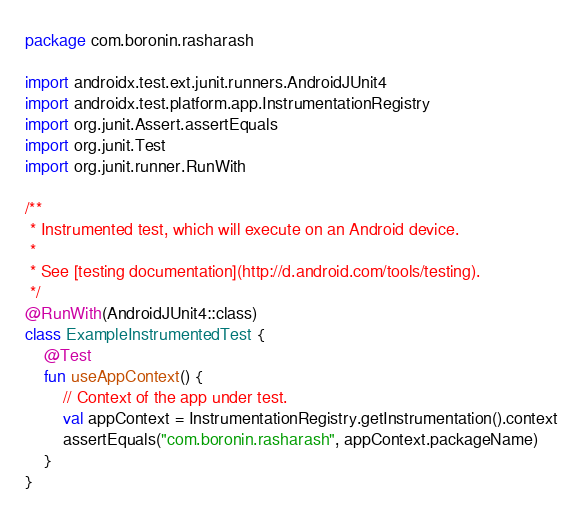Convert code to text. <code><loc_0><loc_0><loc_500><loc_500><_Kotlin_>package com.boronin.rasharash

import androidx.test.ext.junit.runners.AndroidJUnit4
import androidx.test.platform.app.InstrumentationRegistry
import org.junit.Assert.assertEquals
import org.junit.Test
import org.junit.runner.RunWith

/**
 * Instrumented test, which will execute on an Android device.
 *
 * See [testing documentation](http://d.android.com/tools/testing).
 */
@RunWith(AndroidJUnit4::class)
class ExampleInstrumentedTest {
    @Test
    fun useAppContext() {
        // Context of the app under test.
        val appContext = InstrumentationRegistry.getInstrumentation().context
        assertEquals("com.boronin.rasharash", appContext.packageName)
    }
}
</code> 